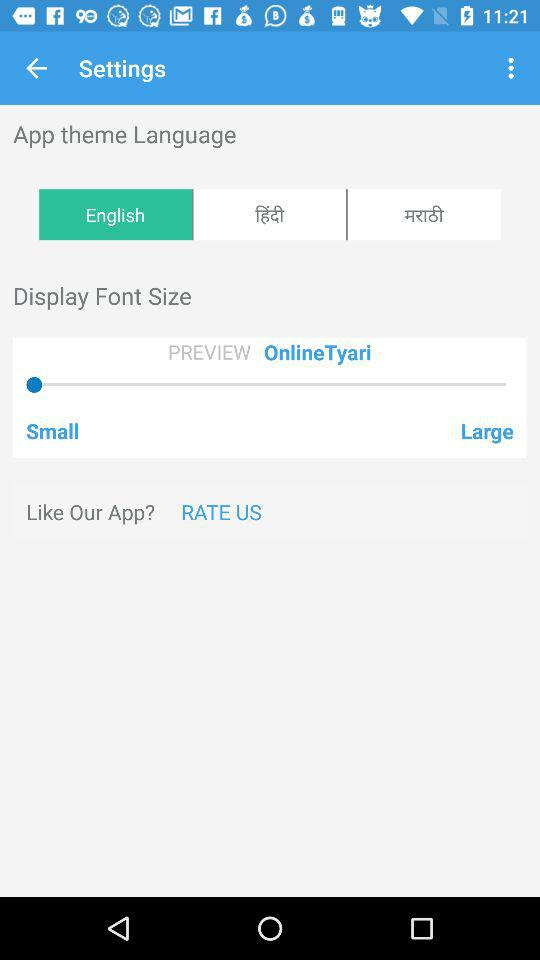What is the rating of the application?
When the provided information is insufficient, respond with <no answer>. <no answer> 